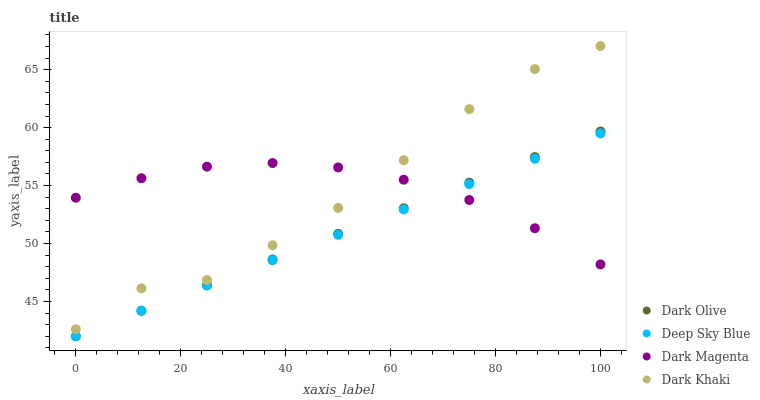Does Deep Sky Blue have the minimum area under the curve?
Answer yes or no. Yes. Does Dark Magenta have the maximum area under the curve?
Answer yes or no. Yes. Does Dark Olive have the minimum area under the curve?
Answer yes or no. No. Does Dark Olive have the maximum area under the curve?
Answer yes or no. No. Is Deep Sky Blue the smoothest?
Answer yes or no. Yes. Is Dark Khaki the roughest?
Answer yes or no. Yes. Is Dark Olive the smoothest?
Answer yes or no. No. Is Dark Olive the roughest?
Answer yes or no. No. Does Dark Olive have the lowest value?
Answer yes or no. Yes. Does Dark Magenta have the lowest value?
Answer yes or no. No. Does Dark Khaki have the highest value?
Answer yes or no. Yes. Does Dark Olive have the highest value?
Answer yes or no. No. Is Dark Olive less than Dark Khaki?
Answer yes or no. Yes. Is Dark Khaki greater than Deep Sky Blue?
Answer yes or no. Yes. Does Dark Magenta intersect Deep Sky Blue?
Answer yes or no. Yes. Is Dark Magenta less than Deep Sky Blue?
Answer yes or no. No. Is Dark Magenta greater than Deep Sky Blue?
Answer yes or no. No. Does Dark Olive intersect Dark Khaki?
Answer yes or no. No. 